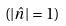Convert formula to latex. <formula><loc_0><loc_0><loc_500><loc_500>( | \hat { n } | = 1 )</formula> 